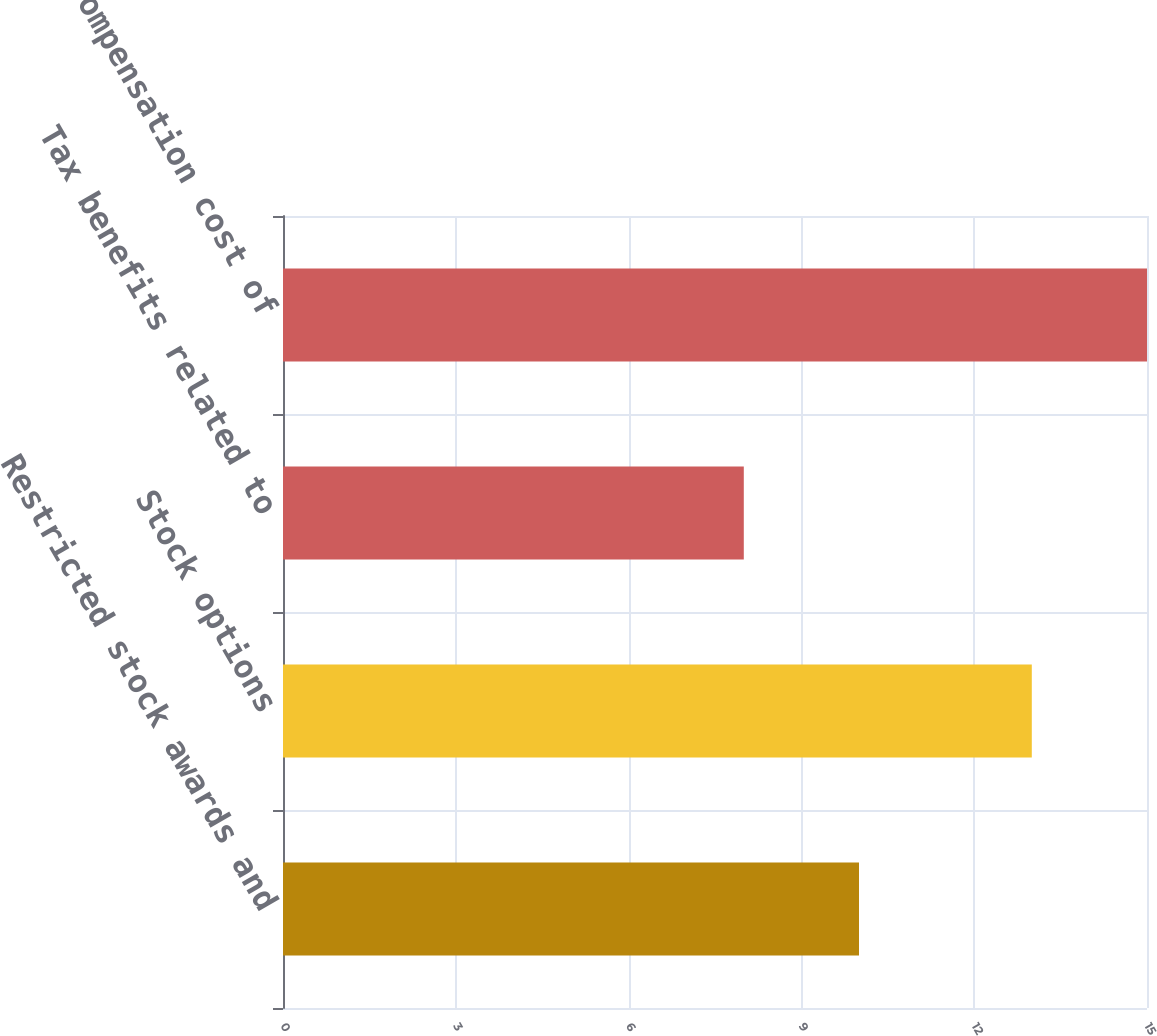Convert chart to OTSL. <chart><loc_0><loc_0><loc_500><loc_500><bar_chart><fcel>Restricted stock awards and<fcel>Stock options<fcel>Tax benefits related to<fcel>Compensation cost of<nl><fcel>10<fcel>13<fcel>8<fcel>15<nl></chart> 